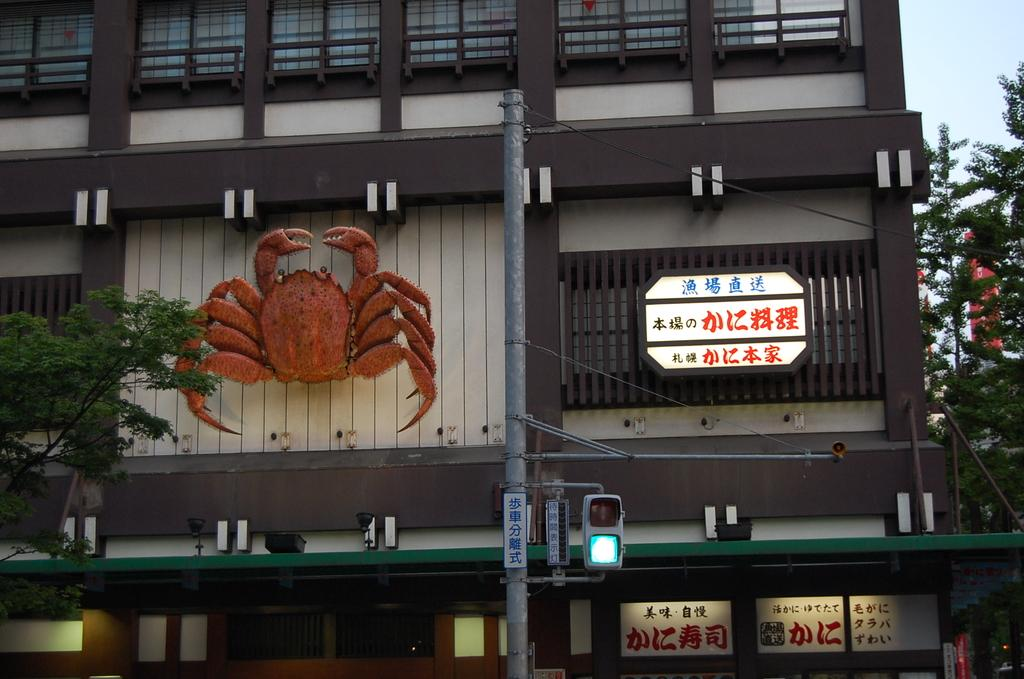What type of natural elements can be seen in the image? There are trees in the image. What man-made objects are present in the image? There are boards, a traffic signal, a pole, a statue on the wall, a building, and a banner in the image. What is the purpose of the traffic signal in the image? The traffic signal in the image is used to regulate traffic. What is the background of the image? The sky is visible in the background of the image. What type of appliance is being used for digestion in the image? There is no appliance or digestion process depicted in the image. 